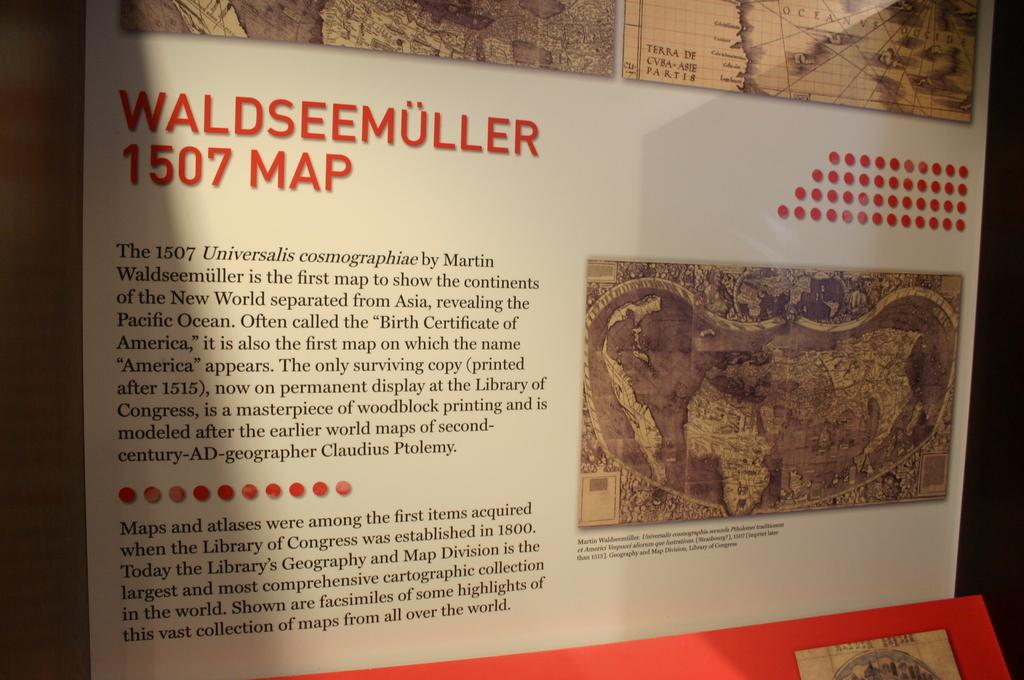<image>
Offer a succinct explanation of the picture presented. A map depicting Waldseemuller in 1507 with a text description. 